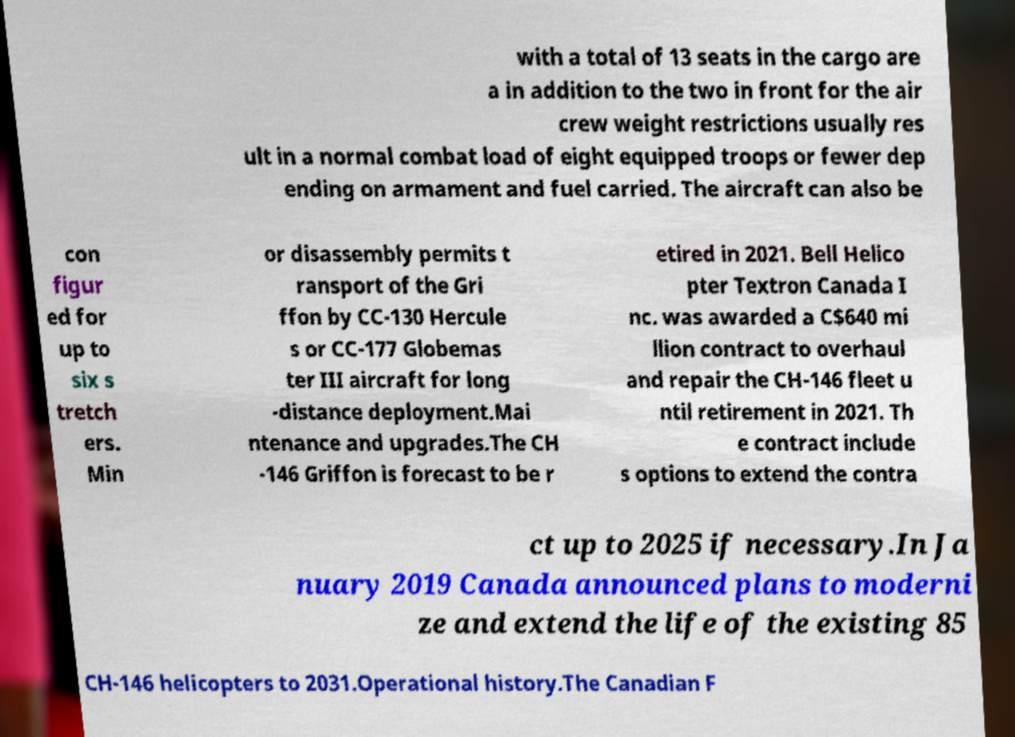What messages or text are displayed in this image? I need them in a readable, typed format. with a total of 13 seats in the cargo are a in addition to the two in front for the air crew weight restrictions usually res ult in a normal combat load of eight equipped troops or fewer dep ending on armament and fuel carried. The aircraft can also be con figur ed for up to six s tretch ers. Min or disassembly permits t ransport of the Gri ffon by CC-130 Hercule s or CC-177 Globemas ter III aircraft for long -distance deployment.Mai ntenance and upgrades.The CH -146 Griffon is forecast to be r etired in 2021. Bell Helico pter Textron Canada I nc. was awarded a C$640 mi llion contract to overhaul and repair the CH-146 fleet u ntil retirement in 2021. Th e contract include s options to extend the contra ct up to 2025 if necessary.In Ja nuary 2019 Canada announced plans to moderni ze and extend the life of the existing 85 CH-146 helicopters to 2031.Operational history.The Canadian F 